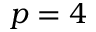Convert formula to latex. <formula><loc_0><loc_0><loc_500><loc_500>p = 4</formula> 